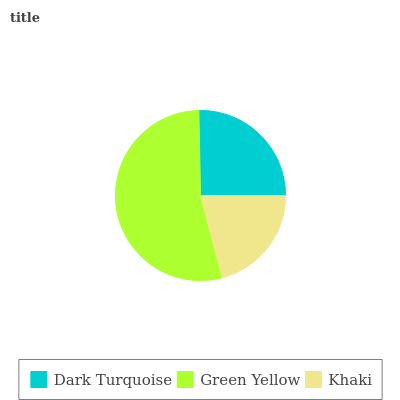Is Khaki the minimum?
Answer yes or no. Yes. Is Green Yellow the maximum?
Answer yes or no. Yes. Is Green Yellow the minimum?
Answer yes or no. No. Is Khaki the maximum?
Answer yes or no. No. Is Green Yellow greater than Khaki?
Answer yes or no. Yes. Is Khaki less than Green Yellow?
Answer yes or no. Yes. Is Khaki greater than Green Yellow?
Answer yes or no. No. Is Green Yellow less than Khaki?
Answer yes or no. No. Is Dark Turquoise the high median?
Answer yes or no. Yes. Is Dark Turquoise the low median?
Answer yes or no. Yes. Is Khaki the high median?
Answer yes or no. No. Is Green Yellow the low median?
Answer yes or no. No. 